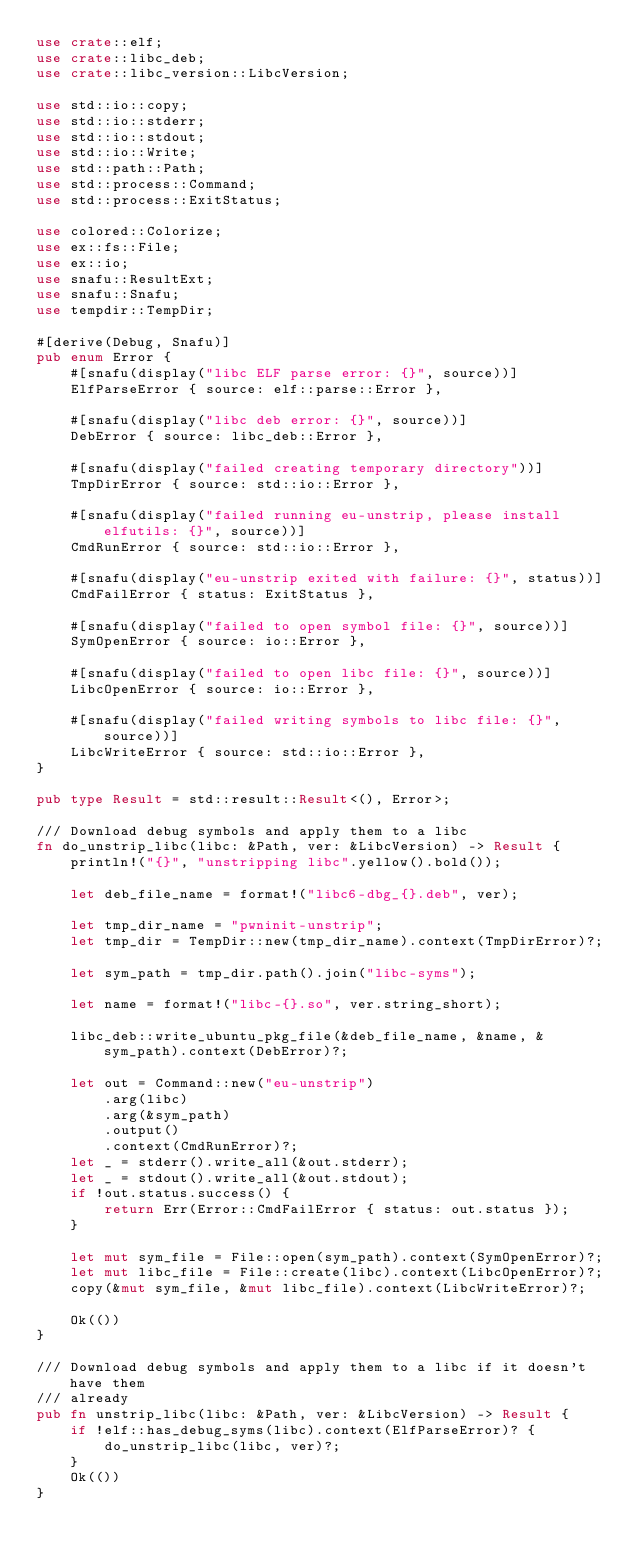<code> <loc_0><loc_0><loc_500><loc_500><_Rust_>use crate::elf;
use crate::libc_deb;
use crate::libc_version::LibcVersion;

use std::io::copy;
use std::io::stderr;
use std::io::stdout;
use std::io::Write;
use std::path::Path;
use std::process::Command;
use std::process::ExitStatus;

use colored::Colorize;
use ex::fs::File;
use ex::io;
use snafu::ResultExt;
use snafu::Snafu;
use tempdir::TempDir;

#[derive(Debug, Snafu)]
pub enum Error {
    #[snafu(display("libc ELF parse error: {}", source))]
    ElfParseError { source: elf::parse::Error },

    #[snafu(display("libc deb error: {}", source))]
    DebError { source: libc_deb::Error },

    #[snafu(display("failed creating temporary directory"))]
    TmpDirError { source: std::io::Error },

    #[snafu(display("failed running eu-unstrip, please install elfutils: {}", source))]
    CmdRunError { source: std::io::Error },

    #[snafu(display("eu-unstrip exited with failure: {}", status))]
    CmdFailError { status: ExitStatus },

    #[snafu(display("failed to open symbol file: {}", source))]
    SymOpenError { source: io::Error },

    #[snafu(display("failed to open libc file: {}", source))]
    LibcOpenError { source: io::Error },

    #[snafu(display("failed writing symbols to libc file: {}", source))]
    LibcWriteError { source: std::io::Error },
}

pub type Result = std::result::Result<(), Error>;

/// Download debug symbols and apply them to a libc
fn do_unstrip_libc(libc: &Path, ver: &LibcVersion) -> Result {
    println!("{}", "unstripping libc".yellow().bold());

    let deb_file_name = format!("libc6-dbg_{}.deb", ver);

    let tmp_dir_name = "pwninit-unstrip";
    let tmp_dir = TempDir::new(tmp_dir_name).context(TmpDirError)?;

    let sym_path = tmp_dir.path().join("libc-syms");

    let name = format!("libc-{}.so", ver.string_short);

    libc_deb::write_ubuntu_pkg_file(&deb_file_name, &name, &sym_path).context(DebError)?;

    let out = Command::new("eu-unstrip")
        .arg(libc)
        .arg(&sym_path)
        .output()
        .context(CmdRunError)?;
    let _ = stderr().write_all(&out.stderr);
    let _ = stdout().write_all(&out.stdout);
    if !out.status.success() {
        return Err(Error::CmdFailError { status: out.status });
    }

    let mut sym_file = File::open(sym_path).context(SymOpenError)?;
    let mut libc_file = File::create(libc).context(LibcOpenError)?;
    copy(&mut sym_file, &mut libc_file).context(LibcWriteError)?;

    Ok(())
}

/// Download debug symbols and apply them to a libc if it doesn't have them
/// already
pub fn unstrip_libc(libc: &Path, ver: &LibcVersion) -> Result {
    if !elf::has_debug_syms(libc).context(ElfParseError)? {
        do_unstrip_libc(libc, ver)?;
    }
    Ok(())
}
</code> 